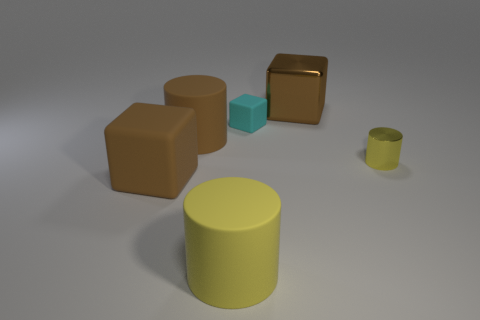Does the small yellow cylinder have the same material as the large cylinder in front of the large brown rubber cube?
Give a very brief answer. No. There is a cylinder to the left of the big yellow cylinder; how big is it?
Your response must be concise. Large. Are there fewer big brown metallic blocks than yellow cylinders?
Your answer should be very brief. Yes. Are there any other metallic cylinders of the same color as the metallic cylinder?
Provide a short and direct response. No. What shape is the large thing that is right of the large brown cylinder and behind the brown rubber block?
Your response must be concise. Cube. What is the shape of the brown rubber object that is on the right side of the large brown cube on the left side of the large yellow matte object?
Offer a terse response. Cylinder. Is the shape of the tiny cyan rubber thing the same as the large shiny object?
Ensure brevity in your answer.  Yes. There is a cylinder that is the same color as the large rubber cube; what is its material?
Make the answer very short. Rubber. Do the tiny metal cylinder and the small cube have the same color?
Keep it short and to the point. No. There is a object that is right of the large brown thing that is on the right side of the tiny cyan rubber cube; what number of big yellow cylinders are in front of it?
Offer a terse response. 1. 